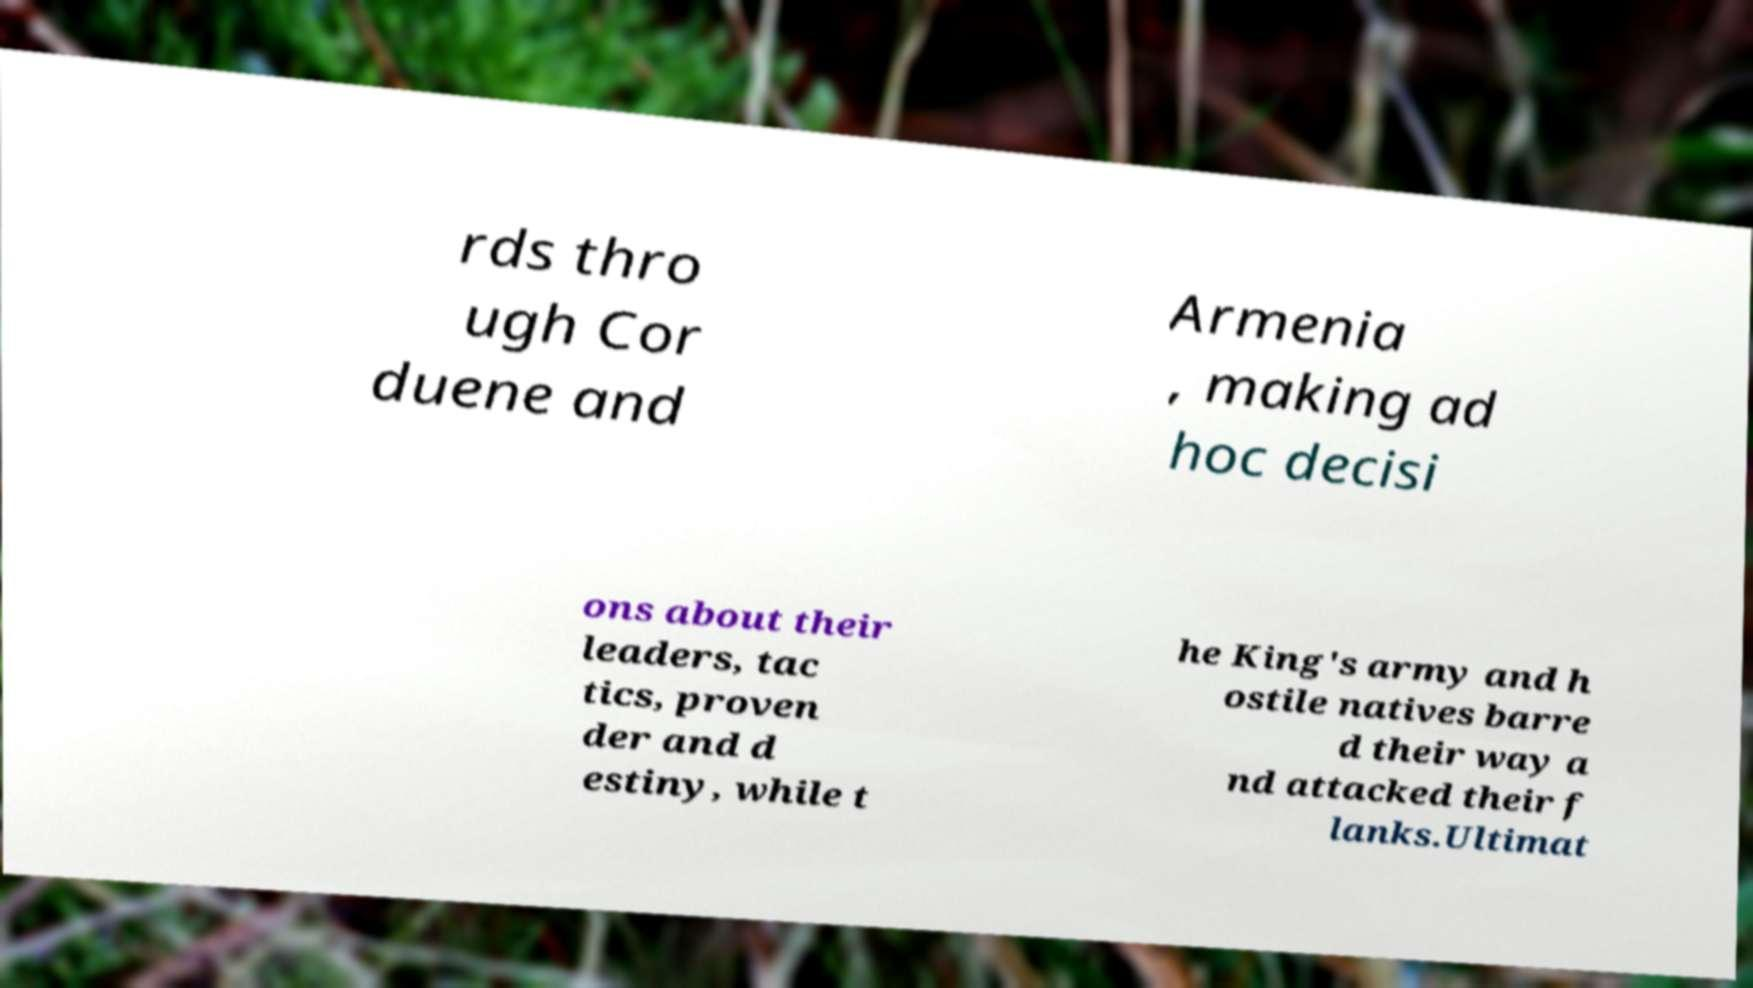Please identify and transcribe the text found in this image. rds thro ugh Cor duene and Armenia , making ad hoc decisi ons about their leaders, tac tics, proven der and d estiny, while t he King's army and h ostile natives barre d their way a nd attacked their f lanks.Ultimat 